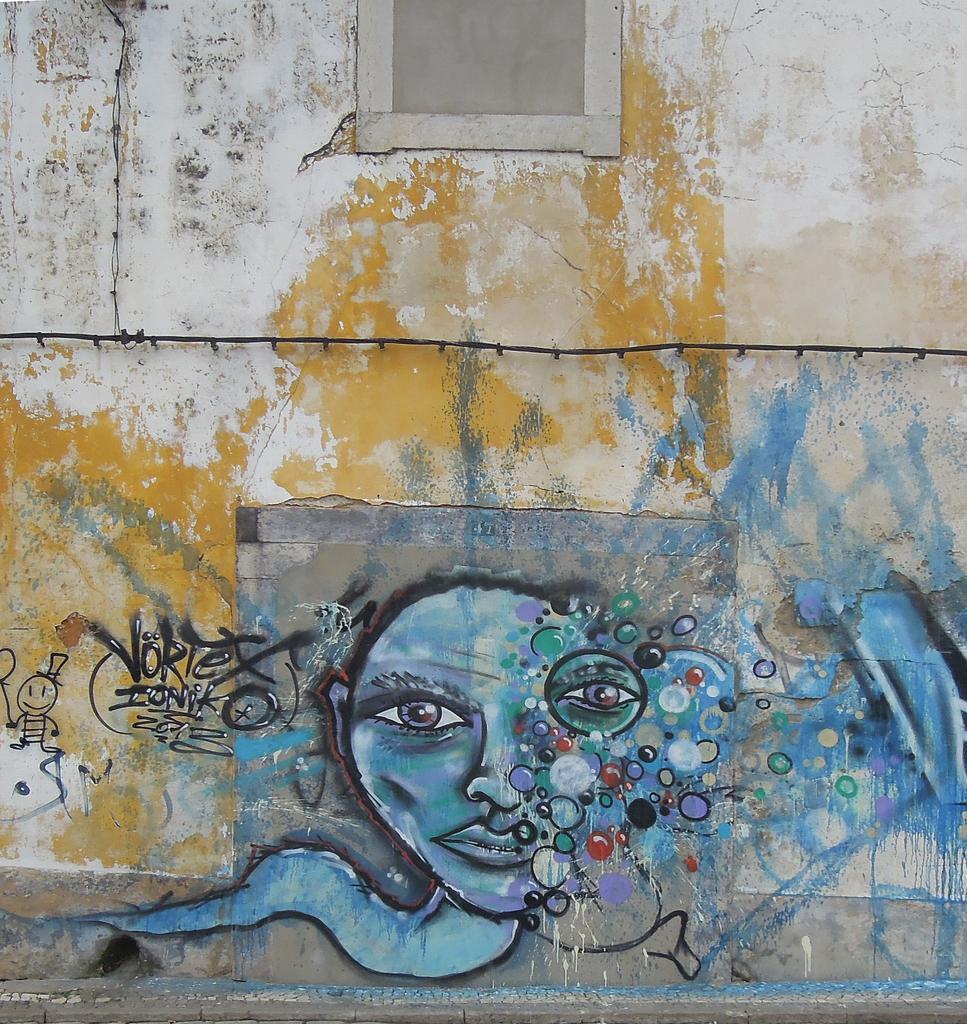Describe this image in one or two sentences. In this picture we can see painting on the wall and some objects. 